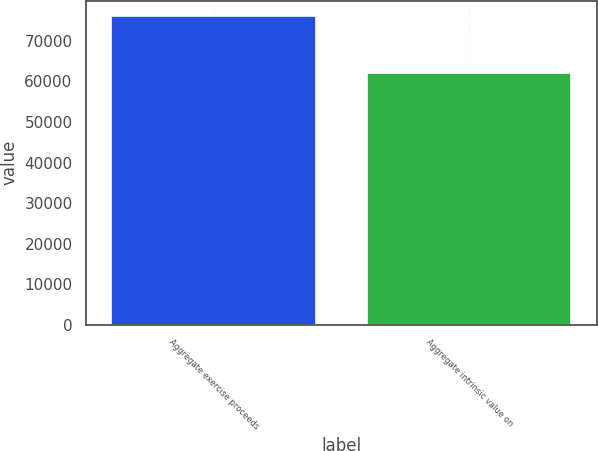Convert chart. <chart><loc_0><loc_0><loc_500><loc_500><bar_chart><fcel>Aggregate exercise proceeds<fcel>Aggregate intrinsic value on<nl><fcel>76153<fcel>62136<nl></chart> 